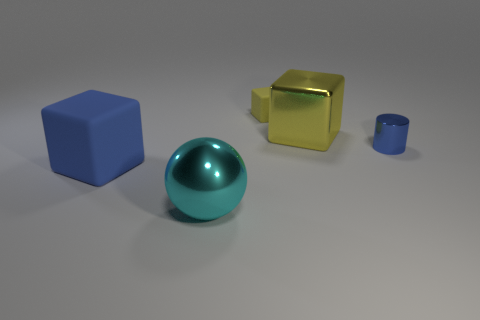Is there anything else that is made of the same material as the large blue block? Yes, the small blue cylinder appears to be made of the same material as the large blue block, displaying a similar color and matte surface texture. 